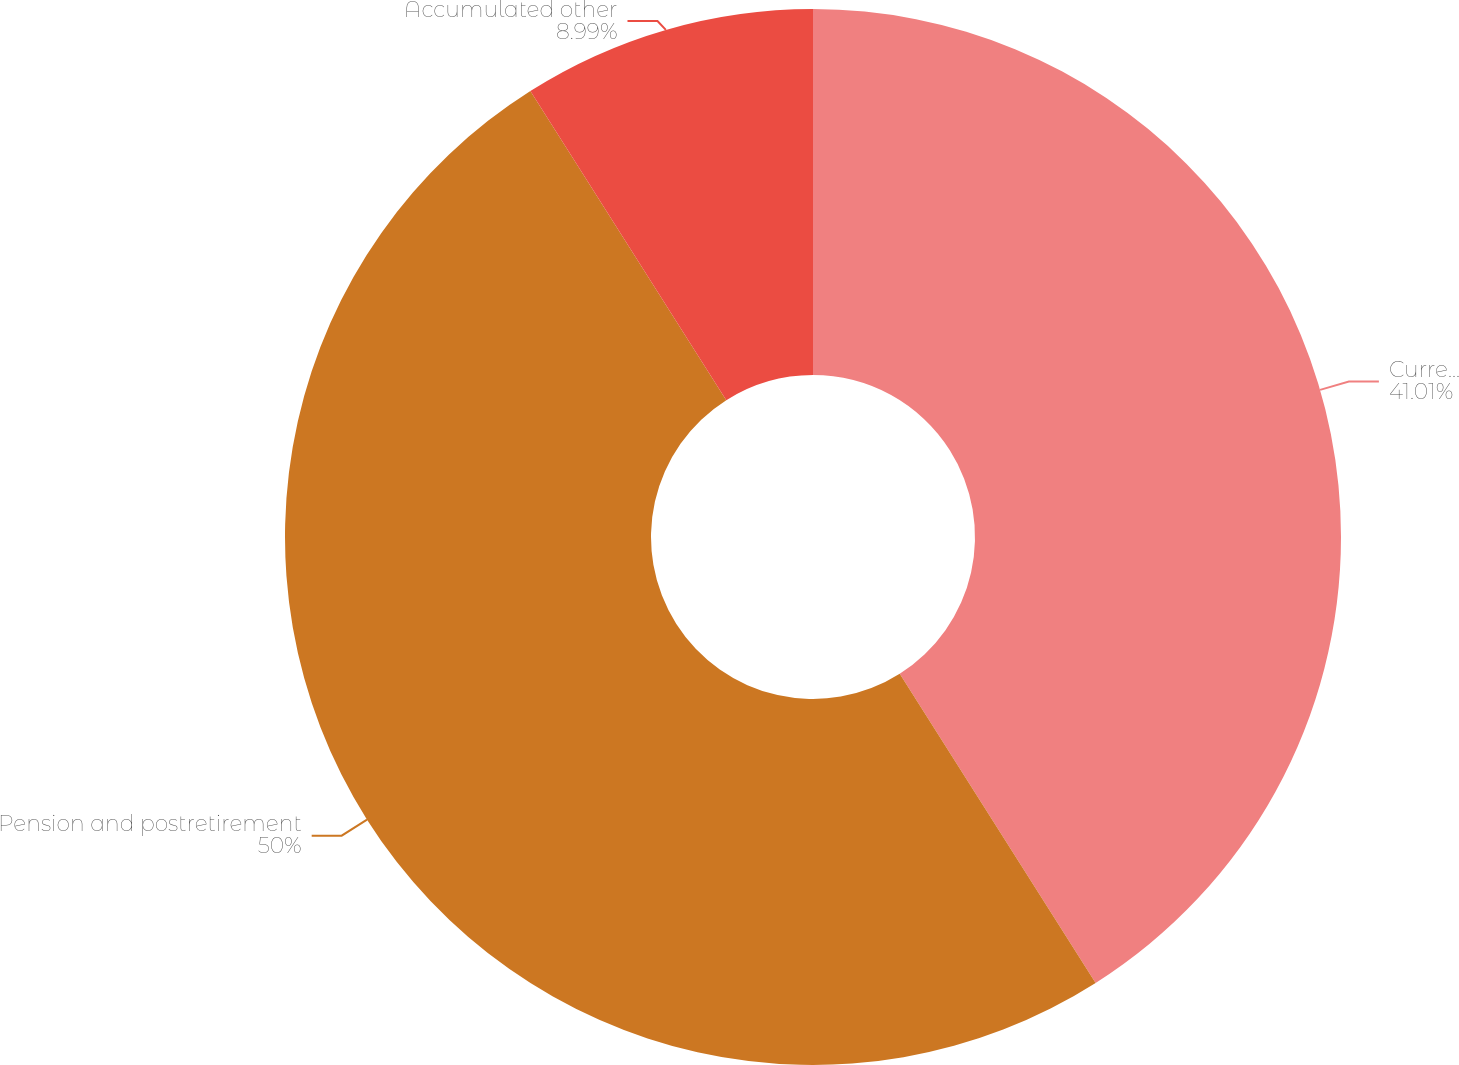Convert chart. <chart><loc_0><loc_0><loc_500><loc_500><pie_chart><fcel>Currency translation<fcel>Pension and postretirement<fcel>Accumulated other<nl><fcel>41.01%<fcel>50.0%<fcel>8.99%<nl></chart> 